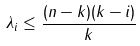Convert formula to latex. <formula><loc_0><loc_0><loc_500><loc_500>\lambda _ { i } \leq \frac { ( n - k ) ( k - i ) } { k }</formula> 